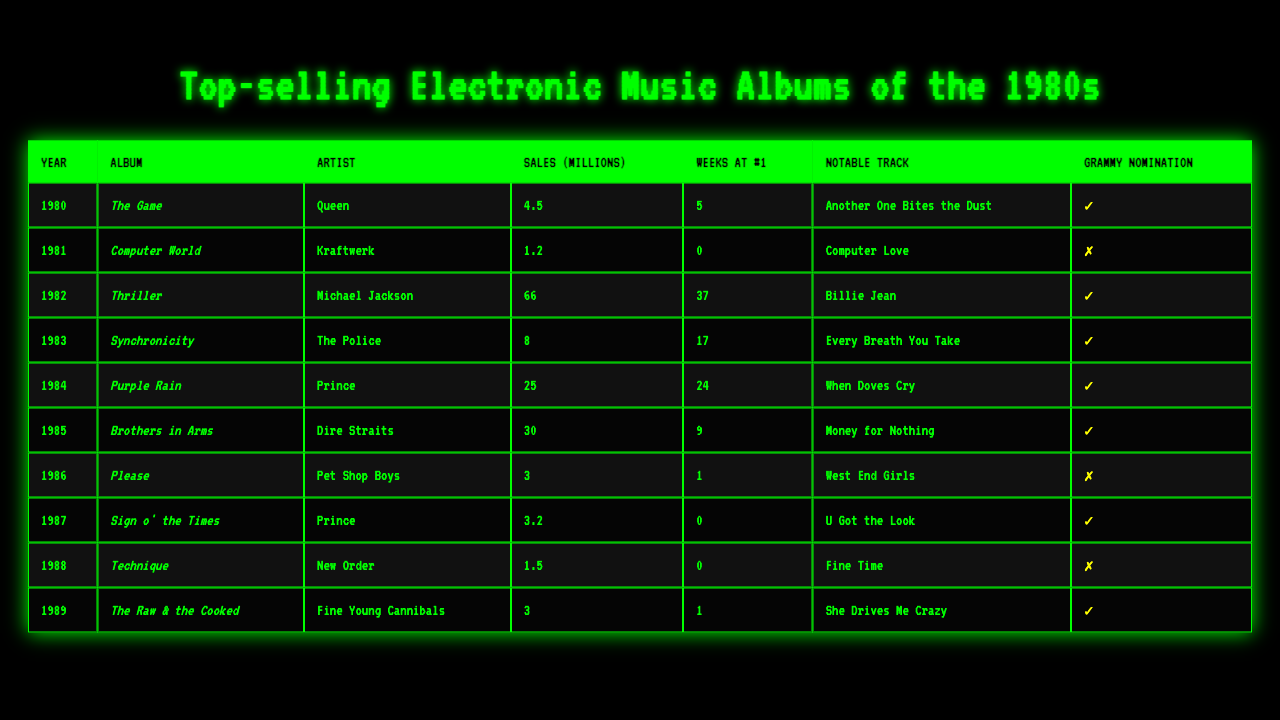What is the top-selling electronic music album of 1982? The table shows that the top-selling album in 1982 is "Thriller" by Michael Jackson, with sales of 66 million.
Answer: Thriller How many weeks did "Purple Rain" stay at #1? The table indicates that "Purple Rain" by Prince stayed at #1 for 24 weeks.
Answer: 24 weeks Do any albums from the table have Grammy nominations? The table lists several albums that have Grammy nominations, indicated by the check mark in the "Grammy Nomination" column.
Answer: Yes Which artist released the album "Please" and what was its sales figure? According to the table, "Please" was released by Pet Shop Boys, and it sold 3 million copies.
Answer: Pet Shop Boys, 3 million What is the combined sales of the top two albums by sales from the table? By looking at the top two albums: "Thriller" with 66 million and "Purple Rain" with 25 million, we add these figures: 66 + 25 = 91 million.
Answer: 91 million Which album had the notable track "Computer Love"? The table reveals that "Computer Love" is the notable track from the album "Computer World" by Kraftwerk, released in 1981.
Answer: Computer World What is the average sales figure of the albums listed for the year 1986? The sales figures for 1986 show a single album, "Please," with sales of 3 million. Therefore, the average sales for that year is just 3 million.
Answer: 3 million Was "Sign o' the Times" nominated for a Grammy? The table indicates that "Sign o' the Times" by Prince received a Grammy nomination, marked by a check.
Answer: Yes How many albums listed had sales greater than 10 million? A careful review of the table shows that three albums had sales greater than 10 million: "Thriller," "Purple Rain," and "Brothers in Arms."
Answer: 3 albums What is the difference in sales between "Technique" and "The Raw & the Cooked"? According to the table, "Technique" sold 1.5 million while "The Raw & the Cooked" sold 3 million. Therefore, the difference in sales is 3 - 1.5 = 1.5 million.
Answer: 1.5 million 